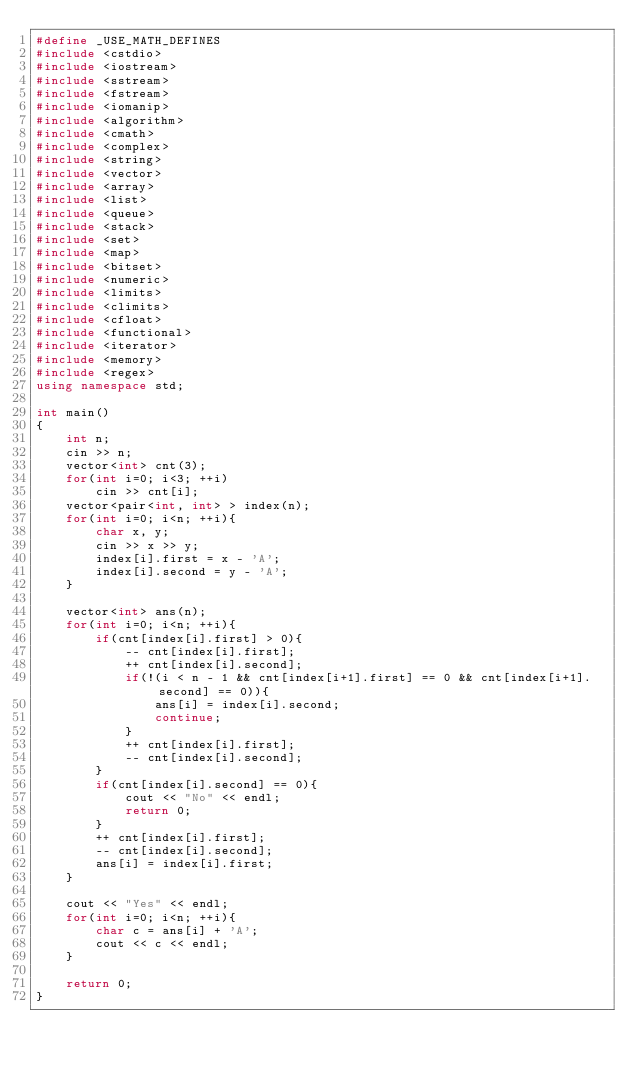<code> <loc_0><loc_0><loc_500><loc_500><_C++_>#define _USE_MATH_DEFINES
#include <cstdio>
#include <iostream>
#include <sstream>
#include <fstream>
#include <iomanip>
#include <algorithm>
#include <cmath>
#include <complex>
#include <string>
#include <vector>
#include <array>
#include <list>
#include <queue>
#include <stack>
#include <set>
#include <map>
#include <bitset>
#include <numeric>
#include <limits>
#include <climits>
#include <cfloat>
#include <functional>
#include <iterator>
#include <memory>
#include <regex>
using namespace std;

int main()
{
    int n;
    cin >> n;
    vector<int> cnt(3);
    for(int i=0; i<3; ++i)
        cin >> cnt[i];
    vector<pair<int, int> > index(n);
    for(int i=0; i<n; ++i){
        char x, y;
        cin >> x >> y;
        index[i].first = x - 'A';
        index[i].second = y - 'A';
    }

    vector<int> ans(n);
    for(int i=0; i<n; ++i){
        if(cnt[index[i].first] > 0){
            -- cnt[index[i].first];
            ++ cnt[index[i].second];
            if(!(i < n - 1 && cnt[index[i+1].first] == 0 && cnt[index[i+1].second] == 0)){
                ans[i] = index[i].second;
                continue;
            }
            ++ cnt[index[i].first];
            -- cnt[index[i].second];
        }
        if(cnt[index[i].second] == 0){
            cout << "No" << endl;
            return 0;
        }
        ++ cnt[index[i].first];
        -- cnt[index[i].second];
        ans[i] = index[i].first;
    }

    cout << "Yes" << endl;
    for(int i=0; i<n; ++i){
        char c = ans[i] + 'A';
        cout << c << endl;
    }

    return 0;
}
</code> 